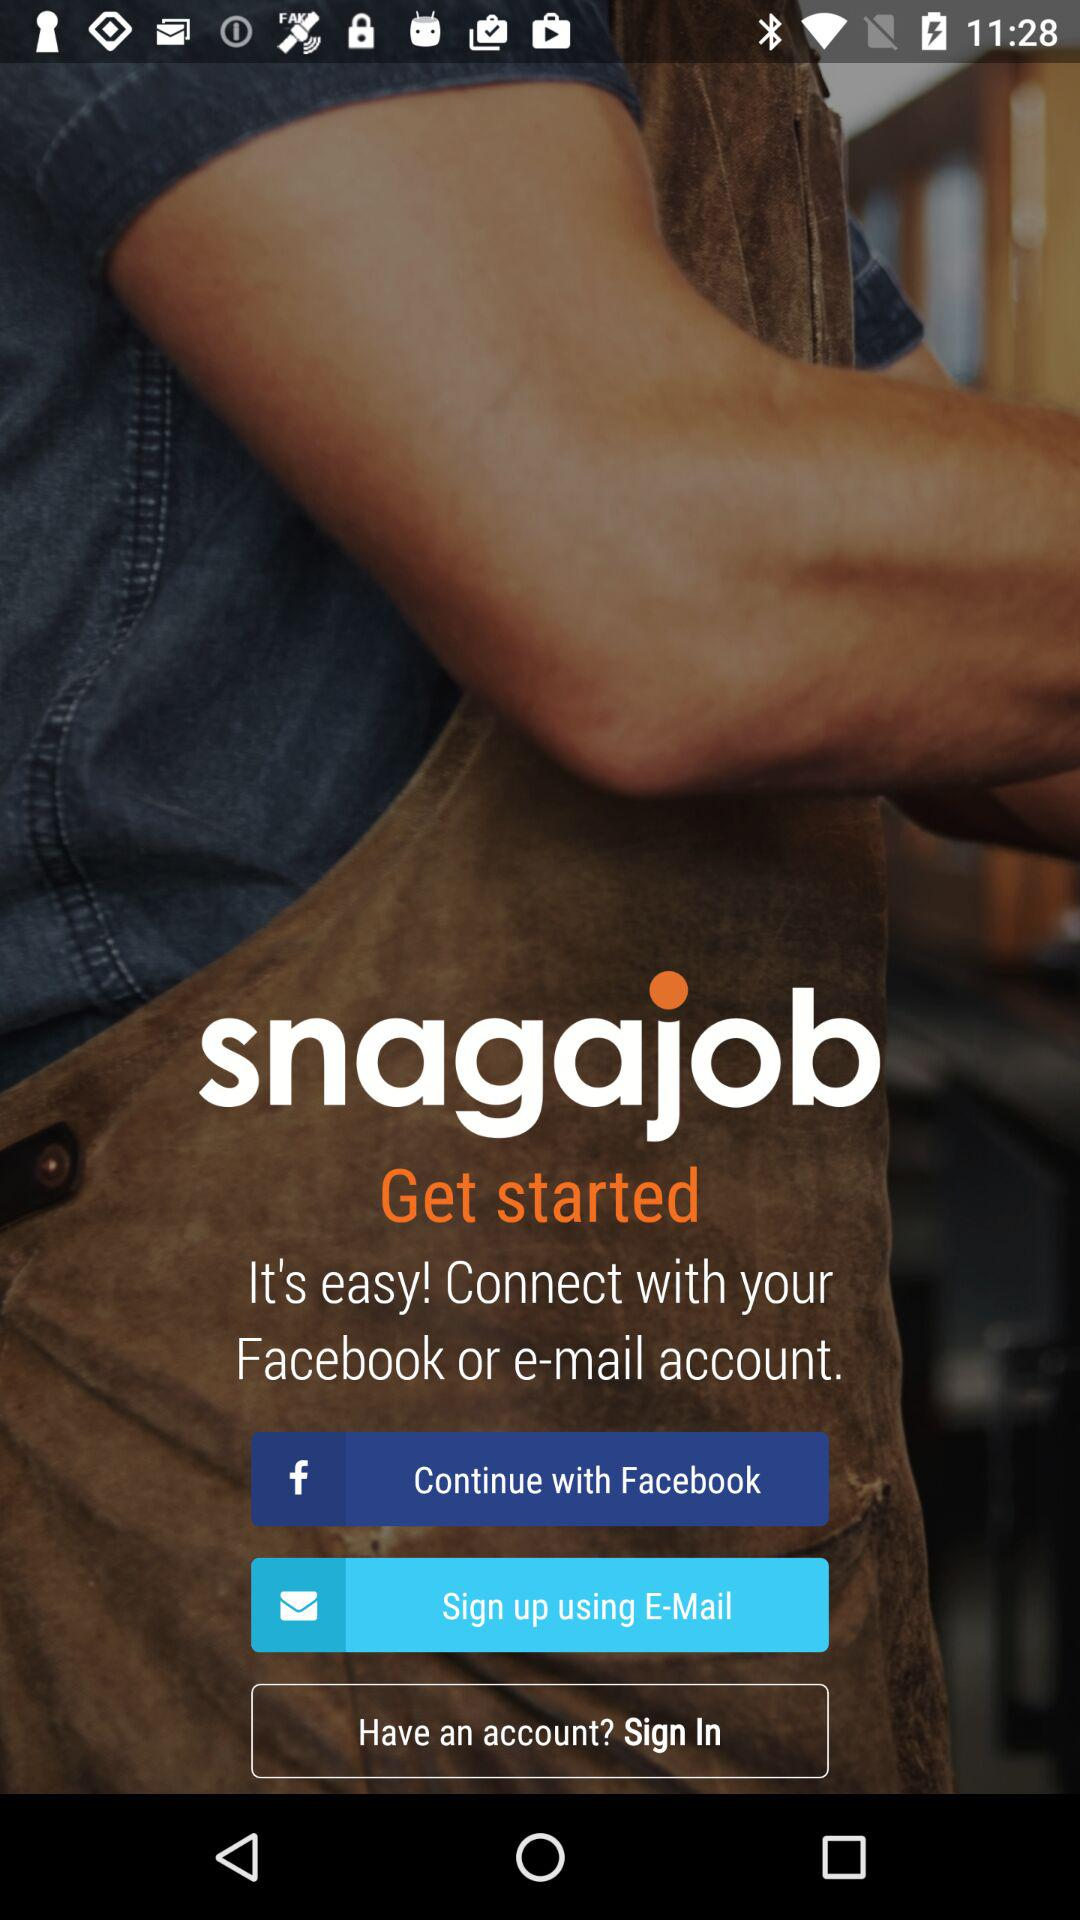What is the name of the application? The name of the application is "Snagajob". 